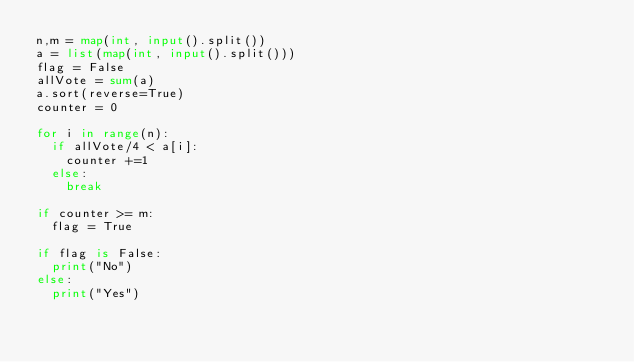<code> <loc_0><loc_0><loc_500><loc_500><_Python_>n,m = map(int, input().split())
a = list(map(int, input().split()))
flag = False
allVote = sum(a)
a.sort(reverse=True)
counter = 0

for i in range(n):
  if allVote/4 < a[i]:
    counter +=1 
  else:
    break

if counter >= m:
  flag = True

if flag is False:
  print("No")
else:
  print("Yes")</code> 